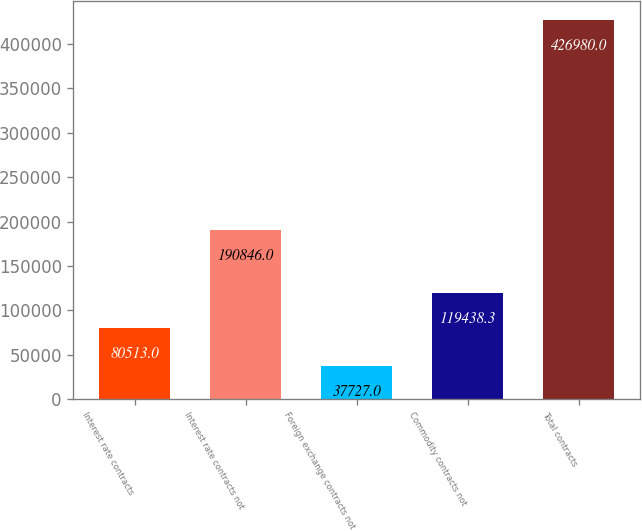Convert chart. <chart><loc_0><loc_0><loc_500><loc_500><bar_chart><fcel>Interest rate contracts<fcel>Interest rate contracts not<fcel>Foreign exchange contracts not<fcel>Commodity contracts not<fcel>Total contracts<nl><fcel>80513<fcel>190846<fcel>37727<fcel>119438<fcel>426980<nl></chart> 